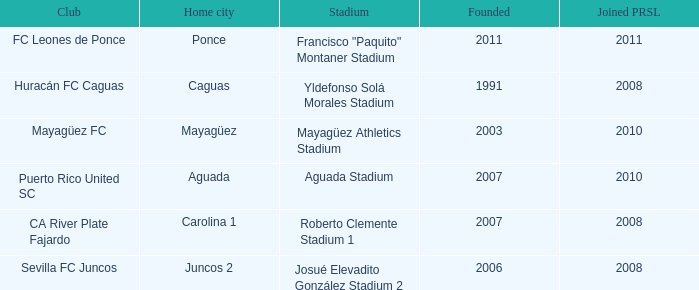At what point in time was the city of mayagüez initially established? 2003.0. 